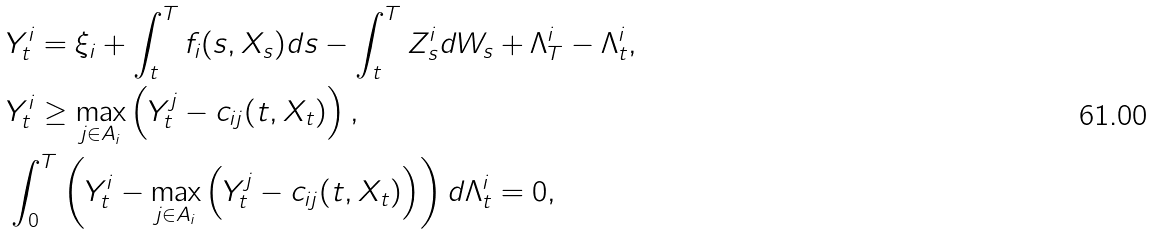<formula> <loc_0><loc_0><loc_500><loc_500>& Y ^ { i } _ { t } = \xi _ { i } + \int _ { t } ^ { T } f _ { i } ( s , X _ { s } ) d s - \int _ { t } ^ { T } Z _ { s } ^ { i } d W _ { s } + \Lambda _ { T } ^ { i } - \Lambda _ { t } ^ { i } , \\ & Y ^ { i } _ { t } \geq \max _ { j \in A _ { i } } \left ( Y ^ { j } _ { t } - c _ { i j } ( t , X _ { t } ) \right ) , \\ & \int _ { 0 } ^ { T } \left ( Y ^ { i } _ { t } - \max _ { j \in A _ { i } } \left ( Y ^ { j } _ { t } - c _ { i j } ( t , X _ { t } ) \right ) \right ) d \Lambda _ { t } ^ { i } = 0 ,</formula> 